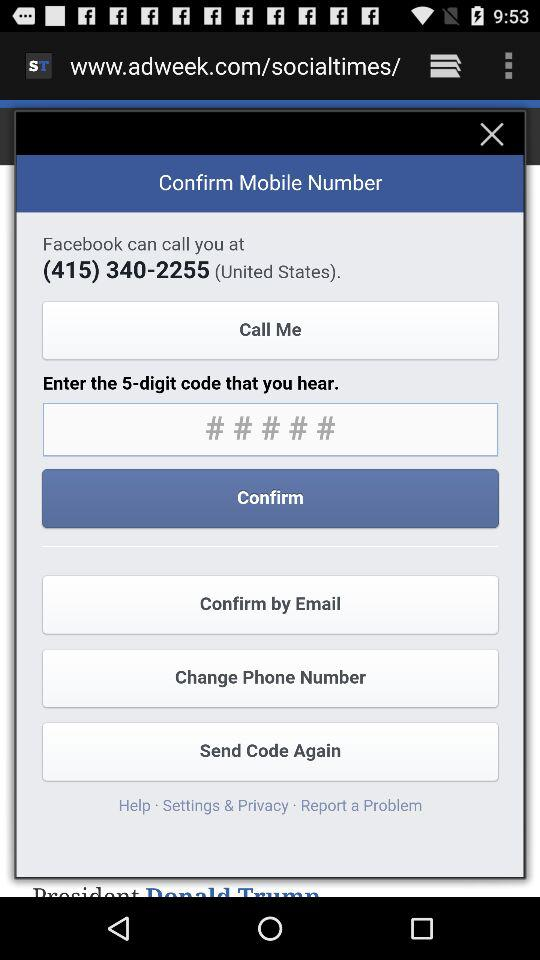How many digits are in the code that I need to enter?
Answer the question using a single word or phrase. 5 